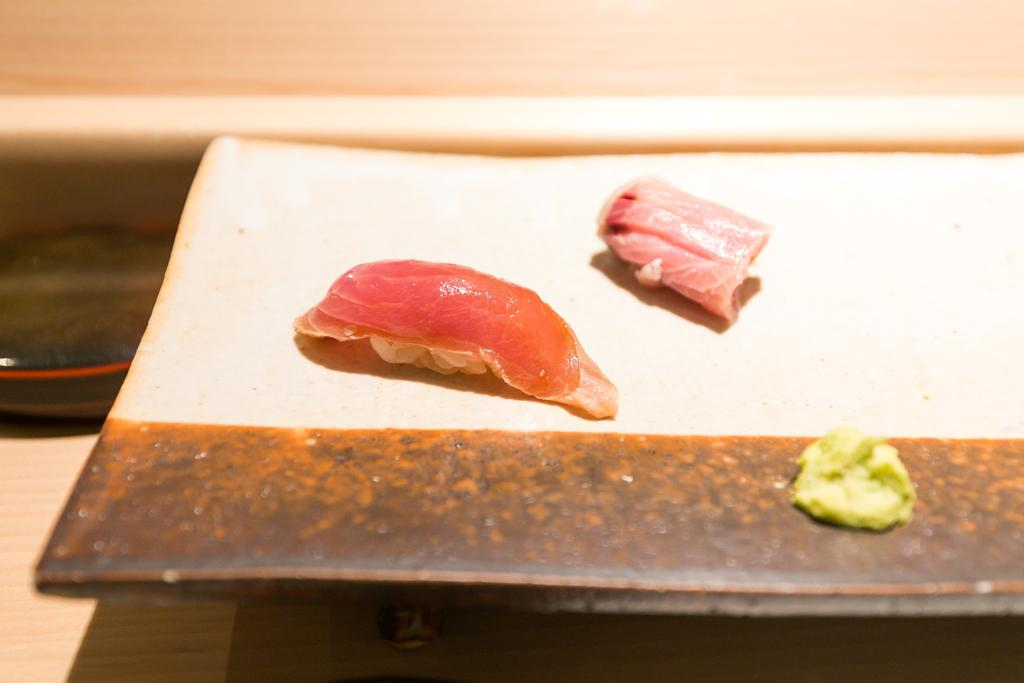What is placed on the plate in the image? There are food items served on a plate. Where is the plate located? The plate is kept on a table. How many tomatoes are on the wrist of the person in the image? There is no person or tomatoes present in the image. What sound does the whistle make in the image? There is no whistle present in the image. 